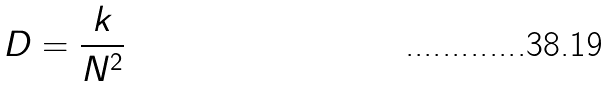<formula> <loc_0><loc_0><loc_500><loc_500>D = \frac { k } { N ^ { 2 } }</formula> 